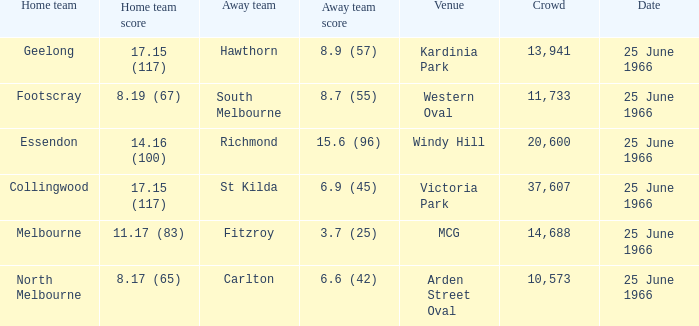Parse the table in full. {'header': ['Home team', 'Home team score', 'Away team', 'Away team score', 'Venue', 'Crowd', 'Date'], 'rows': [['Geelong', '17.15 (117)', 'Hawthorn', '8.9 (57)', 'Kardinia Park', '13,941', '25 June 1966'], ['Footscray', '8.19 (67)', 'South Melbourne', '8.7 (55)', 'Western Oval', '11,733', '25 June 1966'], ['Essendon', '14.16 (100)', 'Richmond', '15.6 (96)', 'Windy Hill', '20,600', '25 June 1966'], ['Collingwood', '17.15 (117)', 'St Kilda', '6.9 (45)', 'Victoria Park', '37,607', '25 June 1966'], ['Melbourne', '11.17 (83)', 'Fitzroy', '3.7 (25)', 'MCG', '14,688', '25 June 1966'], ['North Melbourne', '8.17 (65)', 'Carlton', '6.6 (42)', 'Arden Street Oval', '10,573', '25 June 1966']]} Where did the away team score 8.7 (55)? Western Oval. 